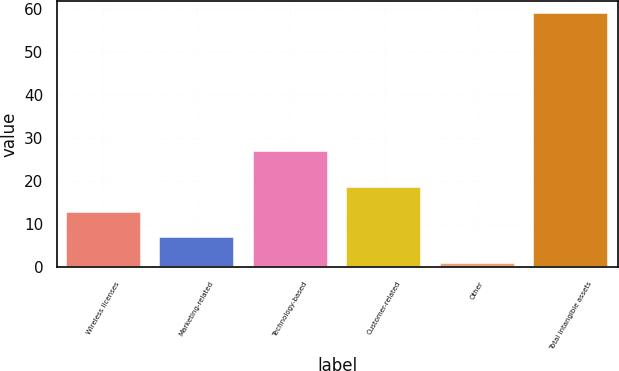<chart> <loc_0><loc_0><loc_500><loc_500><bar_chart><fcel>Wireless licenses<fcel>Marketing-related<fcel>Technology-based<fcel>Customer-related<fcel>Other<fcel>Total intangible assets<nl><fcel>12.8<fcel>7<fcel>27<fcel>18.6<fcel>1<fcel>59<nl></chart> 